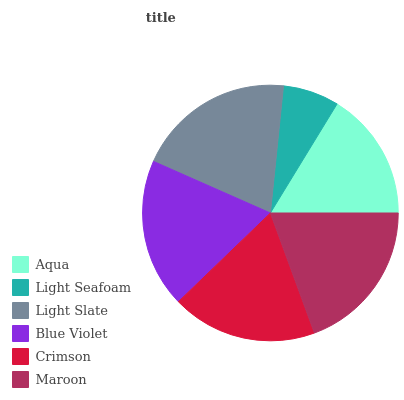Is Light Seafoam the minimum?
Answer yes or no. Yes. Is Light Slate the maximum?
Answer yes or no. Yes. Is Light Slate the minimum?
Answer yes or no. No. Is Light Seafoam the maximum?
Answer yes or no. No. Is Light Slate greater than Light Seafoam?
Answer yes or no. Yes. Is Light Seafoam less than Light Slate?
Answer yes or no. Yes. Is Light Seafoam greater than Light Slate?
Answer yes or no. No. Is Light Slate less than Light Seafoam?
Answer yes or no. No. Is Blue Violet the high median?
Answer yes or no. Yes. Is Crimson the low median?
Answer yes or no. Yes. Is Maroon the high median?
Answer yes or no. No. Is Light Slate the low median?
Answer yes or no. No. 